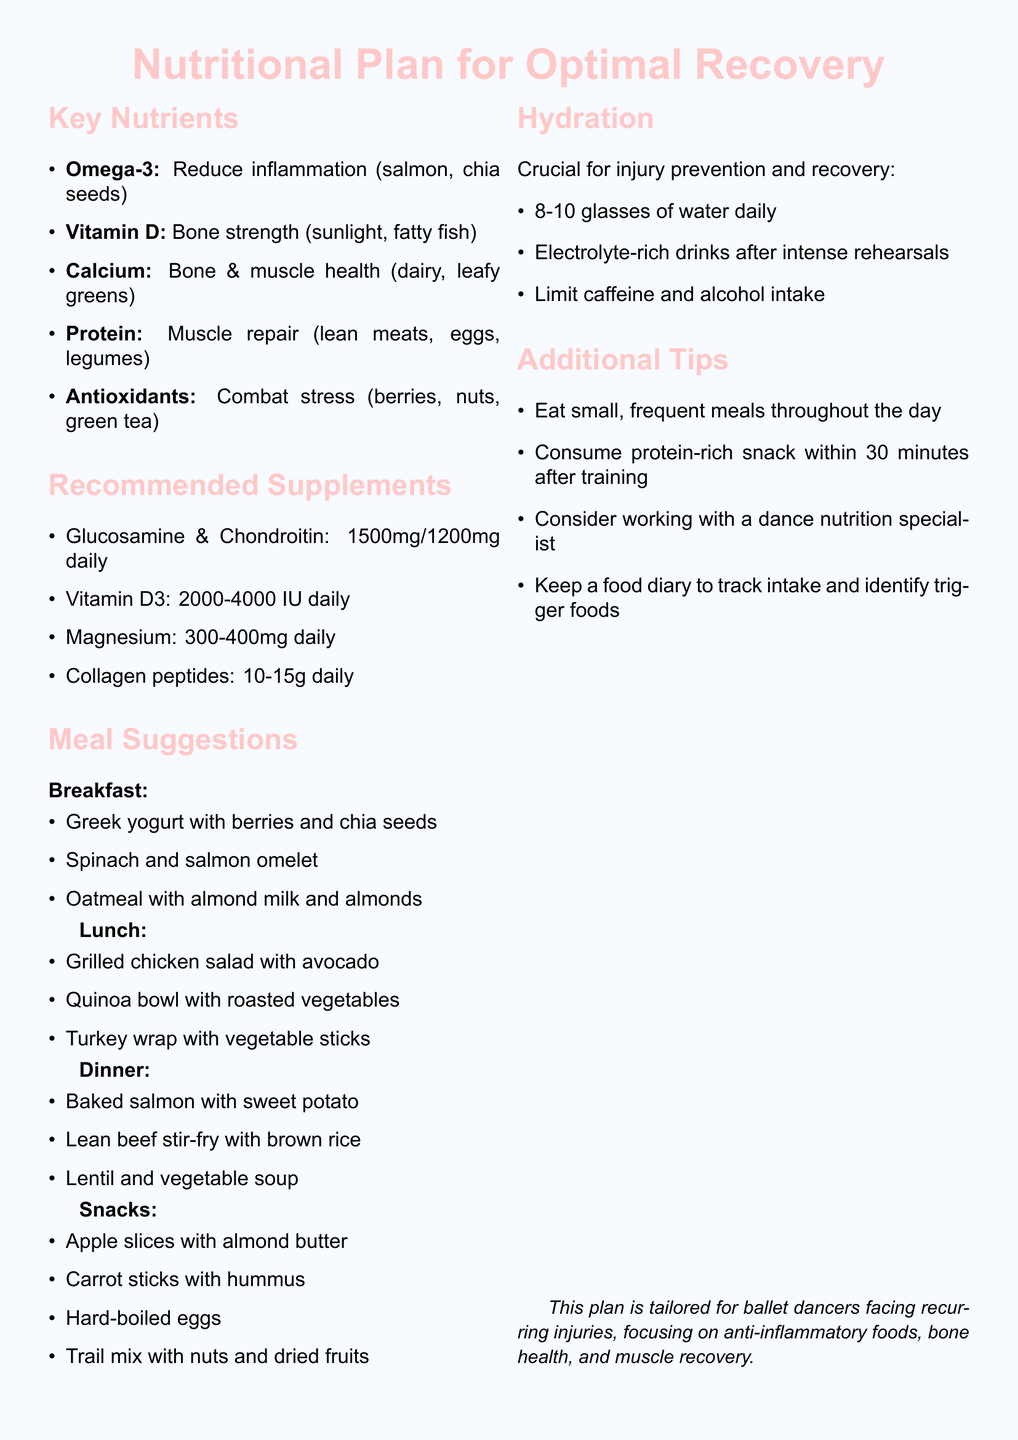What is the title of the memo? The title of the memo, which summarizes the purpose of the document, is "Nutritional Plan for Optimal Recovery and Injury Prevention in Ballet Dancers."
Answer: Nutritional Plan for Optimal Recovery and Injury Prevention in Ballet Dancers What are the key nutrients listed? The memo includes a list of key nutrients that support recovery and injury prevention, which are Omega-3 fatty acids, Vitamin D, Calcium, Protein, and Antioxidants.
Answer: Omega-3 fatty acids, Vitamin D, Calcium, Protein, Antioxidants What is the recommended dosage of Vitamin D3? The memo specifies the recommended daily dosage for Vitamin D3 supplements, which is determined by blood test results, indicated to be between 2000 to 4000 IU.
Answer: 2000-4000 IU daily Which meal suggestion includes salmon? The meal suggestions indicate that salmon is included in both breakfast and dinner options, specifically in the spinach and salmon omelet and the baked salmon with sweet potato.
Answer: Spinach and salmon omelet, Baked salmon with sweet potato How many glasses of water should be consumed daily? The hydration section highlights the importance of water intake, stating a minimum requirement for daily consumption is between 8 to 10 glasses.
Answer: 8-10 glasses What is the purpose of magnesium in the recommended supplements? The memo outlines the purpose of magnesium as supporting muscle recovery and reducing cramping, which is specifically indicated in the supplements section.
Answer: Support muscle recovery and reduce cramping Which food is suggested as a snack? The snack section presents options, suggesting apple slices with almond butter as one of the healthy snack alternatives for dancers.
Answer: Apple slices with almond butter What is a recommended action for personalized nutrition advice? The memo advises considering collaboration with a registered dietitian who specializes in dance nutrition for tailored nutritional guidance.
Answer: Work with a registered dietitian 